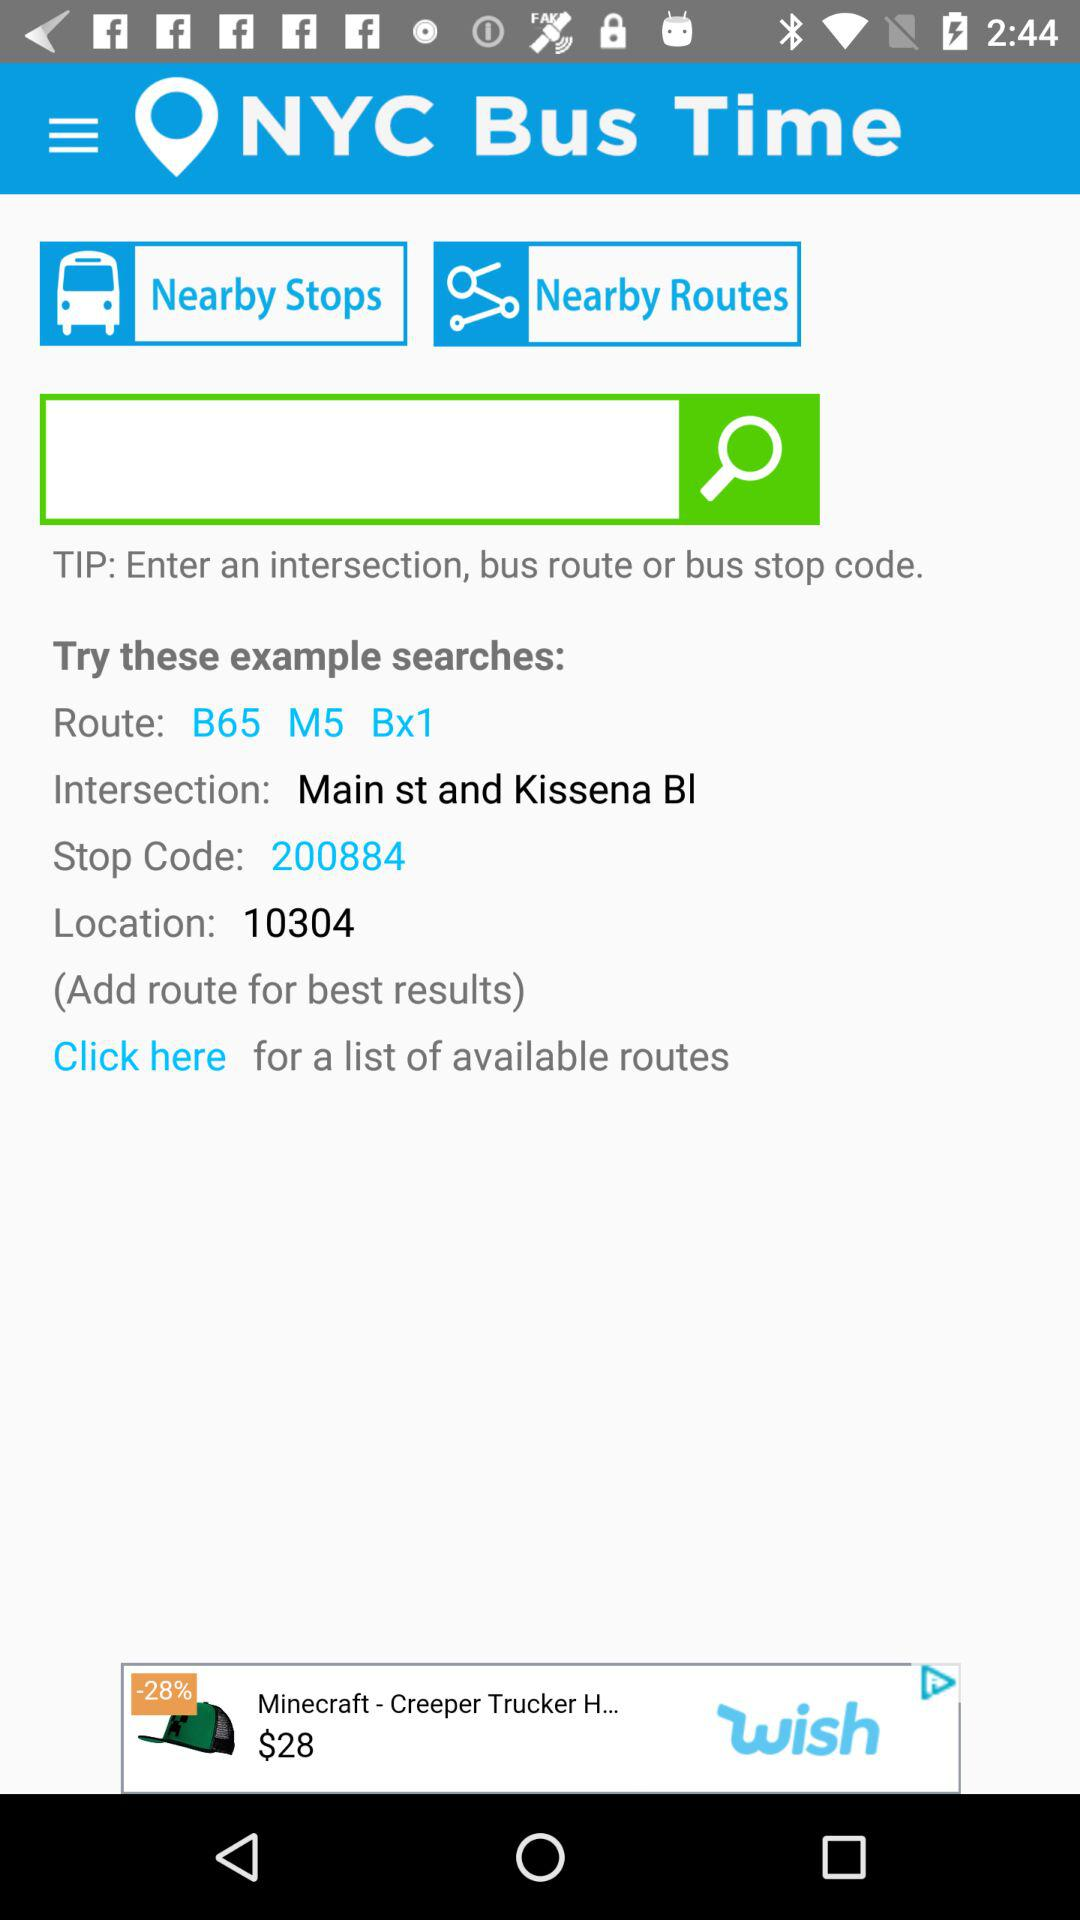What is the intersection point? The intersection point is Main St. and Kissena Blvd. 